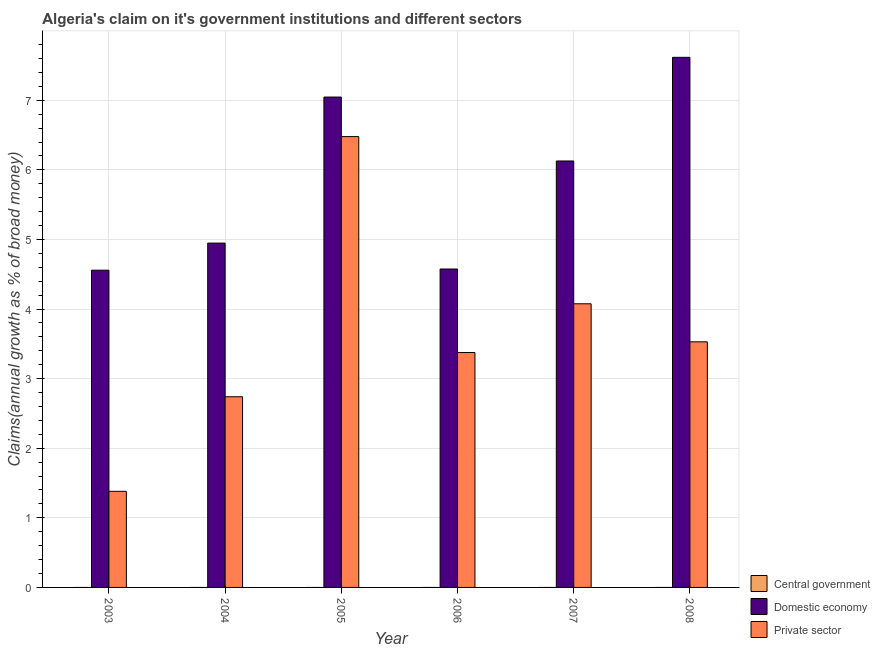Are the number of bars per tick equal to the number of legend labels?
Give a very brief answer. No. Are the number of bars on each tick of the X-axis equal?
Your answer should be compact. Yes. How many bars are there on the 3rd tick from the left?
Ensure brevity in your answer.  2. How many bars are there on the 3rd tick from the right?
Ensure brevity in your answer.  2. In how many cases, is the number of bars for a given year not equal to the number of legend labels?
Offer a very short reply. 6. What is the percentage of claim on the central government in 2008?
Ensure brevity in your answer.  0. Across all years, what is the maximum percentage of claim on the domestic economy?
Make the answer very short. 7.62. Across all years, what is the minimum percentage of claim on the private sector?
Make the answer very short. 1.38. What is the total percentage of claim on the private sector in the graph?
Offer a terse response. 21.58. What is the difference between the percentage of claim on the private sector in 2003 and that in 2004?
Your response must be concise. -1.36. What is the difference between the percentage of claim on the central government in 2008 and the percentage of claim on the private sector in 2004?
Ensure brevity in your answer.  0. What is the ratio of the percentage of claim on the private sector in 2005 to that in 2006?
Your answer should be very brief. 1.92. What is the difference between the highest and the second highest percentage of claim on the private sector?
Give a very brief answer. 2.4. What is the difference between the highest and the lowest percentage of claim on the private sector?
Keep it short and to the point. 5.1. Is it the case that in every year, the sum of the percentage of claim on the central government and percentage of claim on the domestic economy is greater than the percentage of claim on the private sector?
Provide a succinct answer. Yes. How many bars are there?
Provide a short and direct response. 12. What is the difference between two consecutive major ticks on the Y-axis?
Make the answer very short. 1. Does the graph contain any zero values?
Offer a very short reply. Yes. Does the graph contain grids?
Ensure brevity in your answer.  Yes. Where does the legend appear in the graph?
Your answer should be compact. Bottom right. How are the legend labels stacked?
Offer a terse response. Vertical. What is the title of the graph?
Offer a very short reply. Algeria's claim on it's government institutions and different sectors. What is the label or title of the X-axis?
Give a very brief answer. Year. What is the label or title of the Y-axis?
Provide a short and direct response. Claims(annual growth as % of broad money). What is the Claims(annual growth as % of broad money) of Central government in 2003?
Give a very brief answer. 0. What is the Claims(annual growth as % of broad money) of Domestic economy in 2003?
Make the answer very short. 4.56. What is the Claims(annual growth as % of broad money) in Private sector in 2003?
Give a very brief answer. 1.38. What is the Claims(annual growth as % of broad money) of Central government in 2004?
Give a very brief answer. 0. What is the Claims(annual growth as % of broad money) in Domestic economy in 2004?
Your response must be concise. 4.95. What is the Claims(annual growth as % of broad money) of Private sector in 2004?
Your answer should be very brief. 2.74. What is the Claims(annual growth as % of broad money) in Central government in 2005?
Keep it short and to the point. 0. What is the Claims(annual growth as % of broad money) of Domestic economy in 2005?
Make the answer very short. 7.05. What is the Claims(annual growth as % of broad money) of Private sector in 2005?
Your response must be concise. 6.48. What is the Claims(annual growth as % of broad money) of Central government in 2006?
Make the answer very short. 0. What is the Claims(annual growth as % of broad money) in Domestic economy in 2006?
Your answer should be compact. 4.58. What is the Claims(annual growth as % of broad money) in Private sector in 2006?
Offer a terse response. 3.38. What is the Claims(annual growth as % of broad money) of Domestic economy in 2007?
Your answer should be compact. 6.13. What is the Claims(annual growth as % of broad money) in Private sector in 2007?
Ensure brevity in your answer.  4.08. What is the Claims(annual growth as % of broad money) of Central government in 2008?
Ensure brevity in your answer.  0. What is the Claims(annual growth as % of broad money) in Domestic economy in 2008?
Provide a short and direct response. 7.62. What is the Claims(annual growth as % of broad money) of Private sector in 2008?
Give a very brief answer. 3.53. Across all years, what is the maximum Claims(annual growth as % of broad money) of Domestic economy?
Make the answer very short. 7.62. Across all years, what is the maximum Claims(annual growth as % of broad money) of Private sector?
Provide a succinct answer. 6.48. Across all years, what is the minimum Claims(annual growth as % of broad money) of Domestic economy?
Offer a terse response. 4.56. Across all years, what is the minimum Claims(annual growth as % of broad money) of Private sector?
Give a very brief answer. 1.38. What is the total Claims(annual growth as % of broad money) in Domestic economy in the graph?
Provide a short and direct response. 34.87. What is the total Claims(annual growth as % of broad money) of Private sector in the graph?
Ensure brevity in your answer.  21.58. What is the difference between the Claims(annual growth as % of broad money) in Domestic economy in 2003 and that in 2004?
Offer a terse response. -0.39. What is the difference between the Claims(annual growth as % of broad money) of Private sector in 2003 and that in 2004?
Offer a terse response. -1.36. What is the difference between the Claims(annual growth as % of broad money) of Domestic economy in 2003 and that in 2005?
Your answer should be compact. -2.49. What is the difference between the Claims(annual growth as % of broad money) of Private sector in 2003 and that in 2005?
Keep it short and to the point. -5.1. What is the difference between the Claims(annual growth as % of broad money) in Domestic economy in 2003 and that in 2006?
Provide a short and direct response. -0.02. What is the difference between the Claims(annual growth as % of broad money) of Private sector in 2003 and that in 2006?
Provide a succinct answer. -1.99. What is the difference between the Claims(annual growth as % of broad money) of Domestic economy in 2003 and that in 2007?
Provide a succinct answer. -1.57. What is the difference between the Claims(annual growth as % of broad money) in Private sector in 2003 and that in 2007?
Keep it short and to the point. -2.69. What is the difference between the Claims(annual growth as % of broad money) in Domestic economy in 2003 and that in 2008?
Make the answer very short. -3.06. What is the difference between the Claims(annual growth as % of broad money) of Private sector in 2003 and that in 2008?
Your response must be concise. -2.15. What is the difference between the Claims(annual growth as % of broad money) of Domestic economy in 2004 and that in 2005?
Your answer should be very brief. -2.1. What is the difference between the Claims(annual growth as % of broad money) in Private sector in 2004 and that in 2005?
Make the answer very short. -3.74. What is the difference between the Claims(annual growth as % of broad money) of Domestic economy in 2004 and that in 2006?
Make the answer very short. 0.37. What is the difference between the Claims(annual growth as % of broad money) of Private sector in 2004 and that in 2006?
Keep it short and to the point. -0.64. What is the difference between the Claims(annual growth as % of broad money) of Domestic economy in 2004 and that in 2007?
Your answer should be very brief. -1.18. What is the difference between the Claims(annual growth as % of broad money) of Private sector in 2004 and that in 2007?
Your answer should be compact. -1.34. What is the difference between the Claims(annual growth as % of broad money) in Domestic economy in 2004 and that in 2008?
Provide a succinct answer. -2.67. What is the difference between the Claims(annual growth as % of broad money) of Private sector in 2004 and that in 2008?
Your answer should be very brief. -0.79. What is the difference between the Claims(annual growth as % of broad money) of Domestic economy in 2005 and that in 2006?
Ensure brevity in your answer.  2.47. What is the difference between the Claims(annual growth as % of broad money) in Private sector in 2005 and that in 2006?
Provide a succinct answer. 3.1. What is the difference between the Claims(annual growth as % of broad money) in Domestic economy in 2005 and that in 2007?
Provide a succinct answer. 0.92. What is the difference between the Claims(annual growth as % of broad money) of Private sector in 2005 and that in 2007?
Your response must be concise. 2.4. What is the difference between the Claims(annual growth as % of broad money) of Domestic economy in 2005 and that in 2008?
Offer a very short reply. -0.57. What is the difference between the Claims(annual growth as % of broad money) in Private sector in 2005 and that in 2008?
Ensure brevity in your answer.  2.95. What is the difference between the Claims(annual growth as % of broad money) in Domestic economy in 2006 and that in 2007?
Give a very brief answer. -1.55. What is the difference between the Claims(annual growth as % of broad money) of Private sector in 2006 and that in 2007?
Your response must be concise. -0.7. What is the difference between the Claims(annual growth as % of broad money) of Domestic economy in 2006 and that in 2008?
Your response must be concise. -3.04. What is the difference between the Claims(annual growth as % of broad money) in Private sector in 2006 and that in 2008?
Keep it short and to the point. -0.15. What is the difference between the Claims(annual growth as % of broad money) in Domestic economy in 2007 and that in 2008?
Give a very brief answer. -1.49. What is the difference between the Claims(annual growth as % of broad money) of Private sector in 2007 and that in 2008?
Ensure brevity in your answer.  0.55. What is the difference between the Claims(annual growth as % of broad money) of Domestic economy in 2003 and the Claims(annual growth as % of broad money) of Private sector in 2004?
Offer a terse response. 1.82. What is the difference between the Claims(annual growth as % of broad money) in Domestic economy in 2003 and the Claims(annual growth as % of broad money) in Private sector in 2005?
Make the answer very short. -1.92. What is the difference between the Claims(annual growth as % of broad money) in Domestic economy in 2003 and the Claims(annual growth as % of broad money) in Private sector in 2006?
Keep it short and to the point. 1.18. What is the difference between the Claims(annual growth as % of broad money) of Domestic economy in 2003 and the Claims(annual growth as % of broad money) of Private sector in 2007?
Your answer should be very brief. 0.48. What is the difference between the Claims(annual growth as % of broad money) of Domestic economy in 2003 and the Claims(annual growth as % of broad money) of Private sector in 2008?
Give a very brief answer. 1.03. What is the difference between the Claims(annual growth as % of broad money) in Domestic economy in 2004 and the Claims(annual growth as % of broad money) in Private sector in 2005?
Your answer should be compact. -1.53. What is the difference between the Claims(annual growth as % of broad money) of Domestic economy in 2004 and the Claims(annual growth as % of broad money) of Private sector in 2006?
Offer a terse response. 1.57. What is the difference between the Claims(annual growth as % of broad money) of Domestic economy in 2004 and the Claims(annual growth as % of broad money) of Private sector in 2007?
Provide a short and direct response. 0.87. What is the difference between the Claims(annual growth as % of broad money) of Domestic economy in 2004 and the Claims(annual growth as % of broad money) of Private sector in 2008?
Provide a succinct answer. 1.42. What is the difference between the Claims(annual growth as % of broad money) of Domestic economy in 2005 and the Claims(annual growth as % of broad money) of Private sector in 2006?
Your answer should be very brief. 3.67. What is the difference between the Claims(annual growth as % of broad money) of Domestic economy in 2005 and the Claims(annual growth as % of broad money) of Private sector in 2007?
Keep it short and to the point. 2.97. What is the difference between the Claims(annual growth as % of broad money) in Domestic economy in 2005 and the Claims(annual growth as % of broad money) in Private sector in 2008?
Make the answer very short. 3.52. What is the difference between the Claims(annual growth as % of broad money) of Domestic economy in 2006 and the Claims(annual growth as % of broad money) of Private sector in 2007?
Provide a short and direct response. 0.5. What is the difference between the Claims(annual growth as % of broad money) in Domestic economy in 2006 and the Claims(annual growth as % of broad money) in Private sector in 2008?
Your response must be concise. 1.05. What is the difference between the Claims(annual growth as % of broad money) in Domestic economy in 2007 and the Claims(annual growth as % of broad money) in Private sector in 2008?
Your answer should be compact. 2.6. What is the average Claims(annual growth as % of broad money) of Central government per year?
Make the answer very short. 0. What is the average Claims(annual growth as % of broad money) of Domestic economy per year?
Offer a very short reply. 5.81. What is the average Claims(annual growth as % of broad money) in Private sector per year?
Provide a short and direct response. 3.6. In the year 2003, what is the difference between the Claims(annual growth as % of broad money) of Domestic economy and Claims(annual growth as % of broad money) of Private sector?
Ensure brevity in your answer.  3.18. In the year 2004, what is the difference between the Claims(annual growth as % of broad money) of Domestic economy and Claims(annual growth as % of broad money) of Private sector?
Provide a short and direct response. 2.21. In the year 2005, what is the difference between the Claims(annual growth as % of broad money) of Domestic economy and Claims(annual growth as % of broad money) of Private sector?
Keep it short and to the point. 0.57. In the year 2006, what is the difference between the Claims(annual growth as % of broad money) of Domestic economy and Claims(annual growth as % of broad money) of Private sector?
Give a very brief answer. 1.2. In the year 2007, what is the difference between the Claims(annual growth as % of broad money) in Domestic economy and Claims(annual growth as % of broad money) in Private sector?
Provide a short and direct response. 2.05. In the year 2008, what is the difference between the Claims(annual growth as % of broad money) in Domestic economy and Claims(annual growth as % of broad money) in Private sector?
Offer a terse response. 4.09. What is the ratio of the Claims(annual growth as % of broad money) of Domestic economy in 2003 to that in 2004?
Keep it short and to the point. 0.92. What is the ratio of the Claims(annual growth as % of broad money) of Private sector in 2003 to that in 2004?
Make the answer very short. 0.5. What is the ratio of the Claims(annual growth as % of broad money) of Domestic economy in 2003 to that in 2005?
Ensure brevity in your answer.  0.65. What is the ratio of the Claims(annual growth as % of broad money) in Private sector in 2003 to that in 2005?
Your answer should be very brief. 0.21. What is the ratio of the Claims(annual growth as % of broad money) in Private sector in 2003 to that in 2006?
Your answer should be compact. 0.41. What is the ratio of the Claims(annual growth as % of broad money) in Domestic economy in 2003 to that in 2007?
Make the answer very short. 0.74. What is the ratio of the Claims(annual growth as % of broad money) of Private sector in 2003 to that in 2007?
Provide a succinct answer. 0.34. What is the ratio of the Claims(annual growth as % of broad money) in Domestic economy in 2003 to that in 2008?
Offer a terse response. 0.6. What is the ratio of the Claims(annual growth as % of broad money) of Private sector in 2003 to that in 2008?
Give a very brief answer. 0.39. What is the ratio of the Claims(annual growth as % of broad money) in Domestic economy in 2004 to that in 2005?
Your response must be concise. 0.7. What is the ratio of the Claims(annual growth as % of broad money) of Private sector in 2004 to that in 2005?
Offer a terse response. 0.42. What is the ratio of the Claims(annual growth as % of broad money) of Domestic economy in 2004 to that in 2006?
Keep it short and to the point. 1.08. What is the ratio of the Claims(annual growth as % of broad money) in Private sector in 2004 to that in 2006?
Ensure brevity in your answer.  0.81. What is the ratio of the Claims(annual growth as % of broad money) of Domestic economy in 2004 to that in 2007?
Offer a very short reply. 0.81. What is the ratio of the Claims(annual growth as % of broad money) in Private sector in 2004 to that in 2007?
Provide a short and direct response. 0.67. What is the ratio of the Claims(annual growth as % of broad money) in Domestic economy in 2004 to that in 2008?
Provide a succinct answer. 0.65. What is the ratio of the Claims(annual growth as % of broad money) of Private sector in 2004 to that in 2008?
Your response must be concise. 0.78. What is the ratio of the Claims(annual growth as % of broad money) in Domestic economy in 2005 to that in 2006?
Provide a short and direct response. 1.54. What is the ratio of the Claims(annual growth as % of broad money) of Private sector in 2005 to that in 2006?
Your answer should be compact. 1.92. What is the ratio of the Claims(annual growth as % of broad money) of Domestic economy in 2005 to that in 2007?
Offer a terse response. 1.15. What is the ratio of the Claims(annual growth as % of broad money) of Private sector in 2005 to that in 2007?
Ensure brevity in your answer.  1.59. What is the ratio of the Claims(annual growth as % of broad money) in Domestic economy in 2005 to that in 2008?
Your answer should be compact. 0.93. What is the ratio of the Claims(annual growth as % of broad money) in Private sector in 2005 to that in 2008?
Your answer should be compact. 1.84. What is the ratio of the Claims(annual growth as % of broad money) in Domestic economy in 2006 to that in 2007?
Your answer should be compact. 0.75. What is the ratio of the Claims(annual growth as % of broad money) in Private sector in 2006 to that in 2007?
Provide a short and direct response. 0.83. What is the ratio of the Claims(annual growth as % of broad money) of Domestic economy in 2006 to that in 2008?
Keep it short and to the point. 0.6. What is the ratio of the Claims(annual growth as % of broad money) in Private sector in 2006 to that in 2008?
Keep it short and to the point. 0.96. What is the ratio of the Claims(annual growth as % of broad money) of Domestic economy in 2007 to that in 2008?
Keep it short and to the point. 0.8. What is the ratio of the Claims(annual growth as % of broad money) in Private sector in 2007 to that in 2008?
Offer a very short reply. 1.15. What is the difference between the highest and the second highest Claims(annual growth as % of broad money) of Domestic economy?
Give a very brief answer. 0.57. What is the difference between the highest and the second highest Claims(annual growth as % of broad money) of Private sector?
Ensure brevity in your answer.  2.4. What is the difference between the highest and the lowest Claims(annual growth as % of broad money) in Domestic economy?
Your response must be concise. 3.06. What is the difference between the highest and the lowest Claims(annual growth as % of broad money) of Private sector?
Your answer should be very brief. 5.1. 